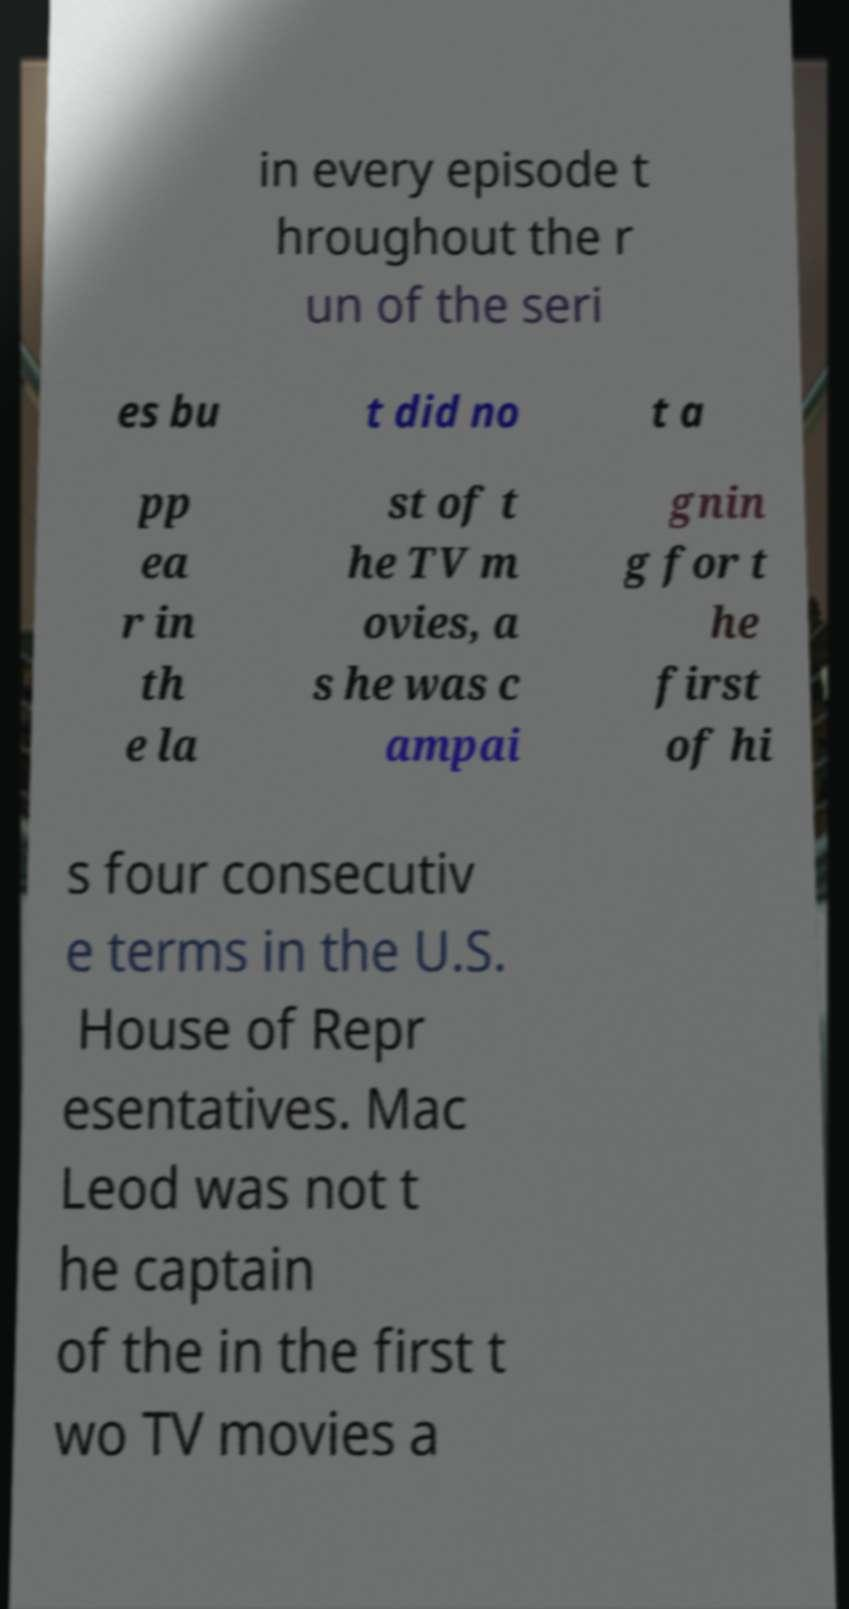I need the written content from this picture converted into text. Can you do that? in every episode t hroughout the r un of the seri es bu t did no t a pp ea r in th e la st of t he TV m ovies, a s he was c ampai gnin g for t he first of hi s four consecutiv e terms in the U.S. House of Repr esentatives. Mac Leod was not t he captain of the in the first t wo TV movies a 